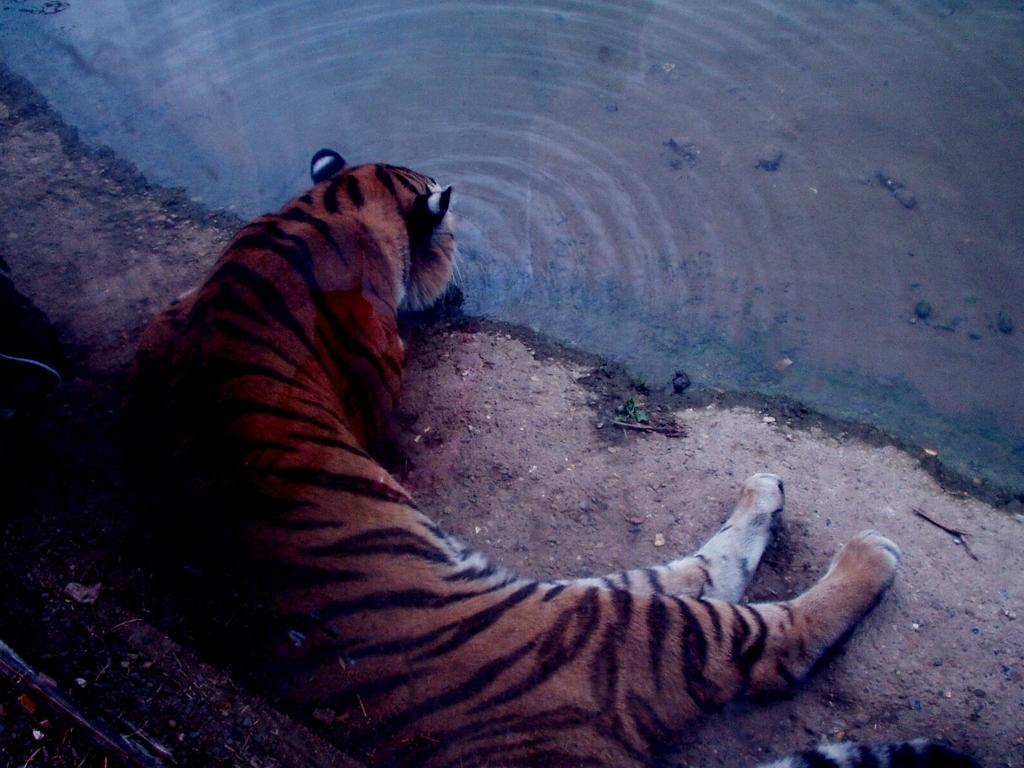Where was the picture taken? The picture was clicked outside the city. What is the main subject in the foreground of the image? There is a tiger in the foreground of the image. What is the tiger doing in the image? The tiger is lying on the ground and drinking water. What can be seen in the background of the image? There is a water body in the background of the image. What color is the lunchroom in the image? There is no lunchroom present in the image; it features a tiger lying on the ground and drinking water outside the city. 